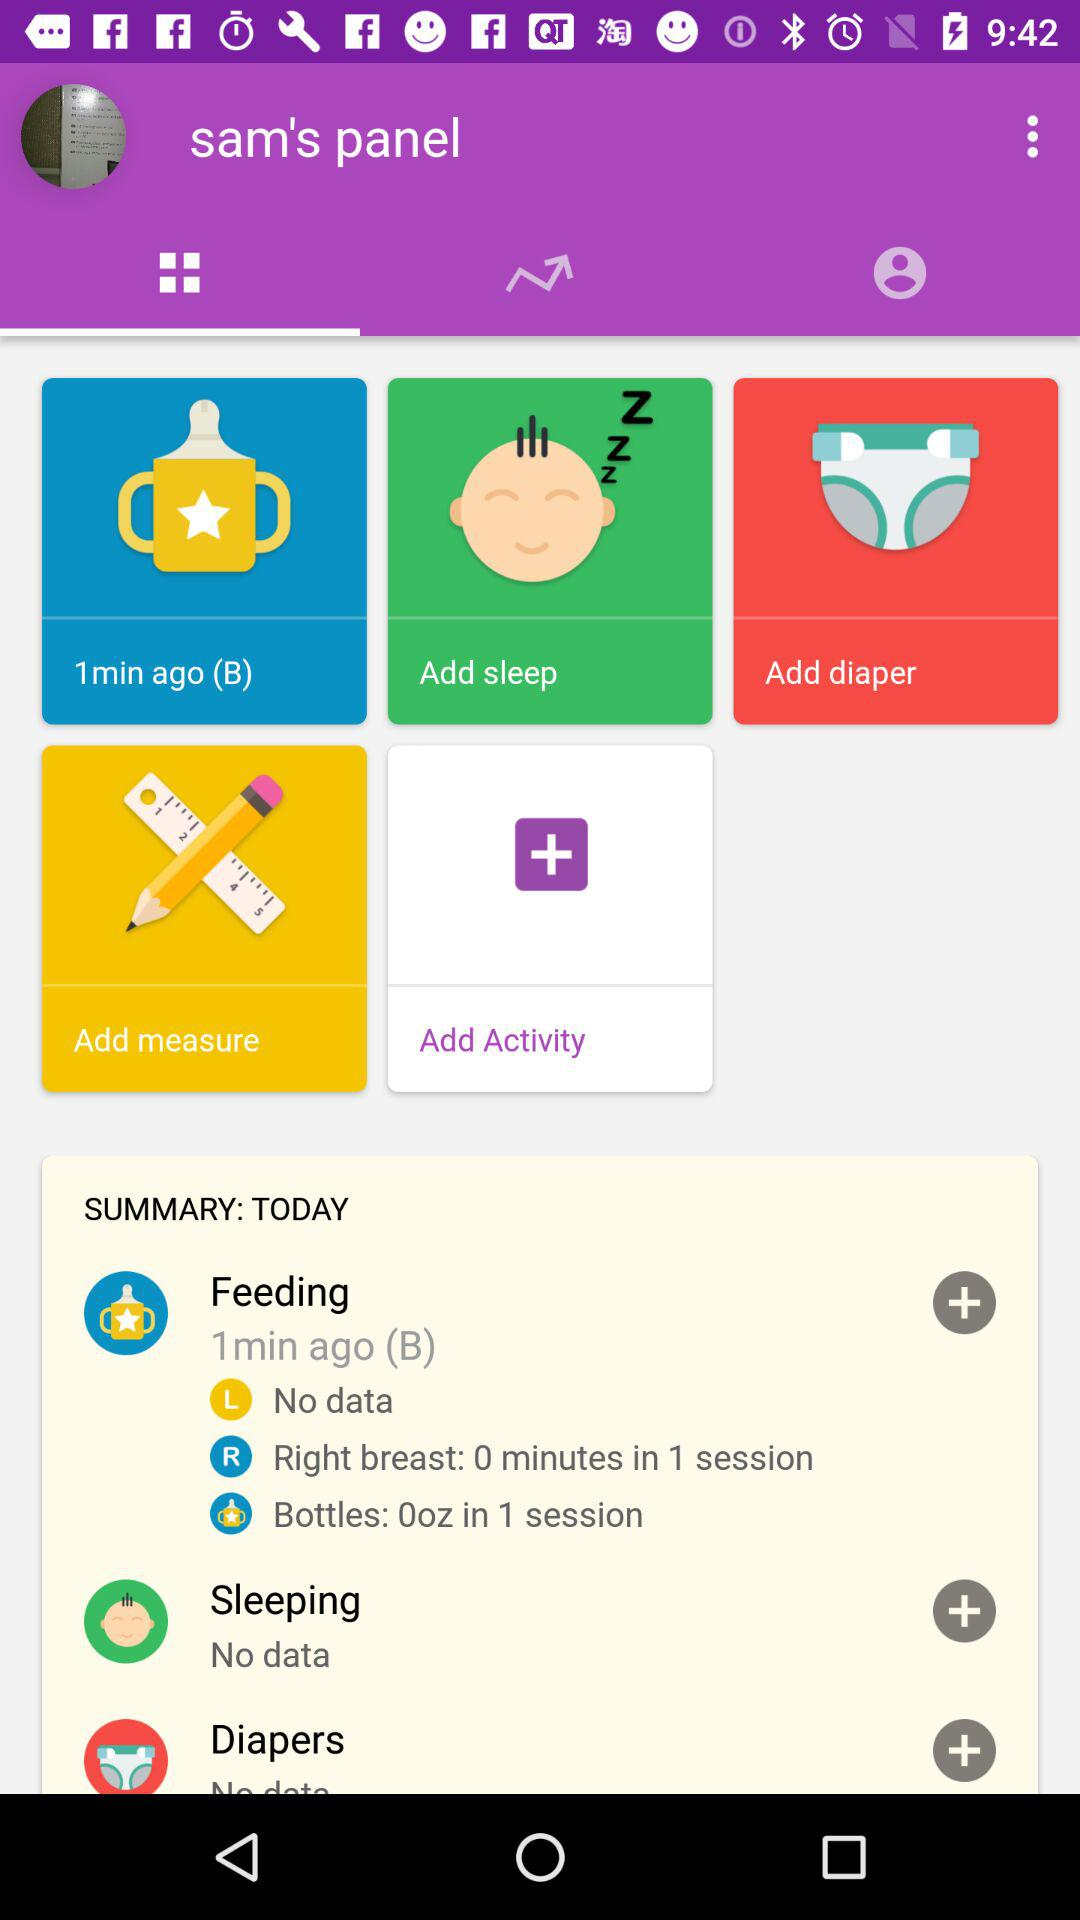Which day is the summary for? The summary is for today. 